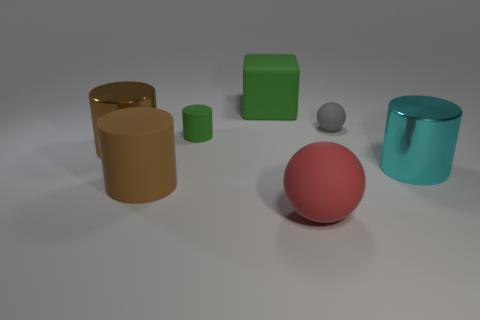There is a small gray rubber sphere; are there any green cylinders in front of it?
Ensure brevity in your answer.  Yes. What number of objects are either big red things or big brown objects?
Give a very brief answer. 3. What number of other objects are there of the same size as the cube?
Provide a succinct answer. 4. How many things are both in front of the small gray sphere and behind the large red matte ball?
Keep it short and to the point. 4. There is a shiny object that is left of the tiny green cylinder; is its size the same as the shiny object on the right side of the large green object?
Offer a terse response. Yes. There is a thing to the left of the brown rubber cylinder; how big is it?
Provide a short and direct response. Large. What number of things are matte things behind the cyan metallic cylinder or large cylinders on the right side of the tiny cylinder?
Offer a terse response. 4. Is there any other thing that has the same color as the big rubber cube?
Ensure brevity in your answer.  Yes. Are there an equal number of green rubber things on the left side of the rubber cube and objects right of the big matte ball?
Provide a short and direct response. No. Is the number of spheres that are on the right side of the red rubber thing greater than the number of tiny yellow rubber cylinders?
Offer a terse response. Yes. 